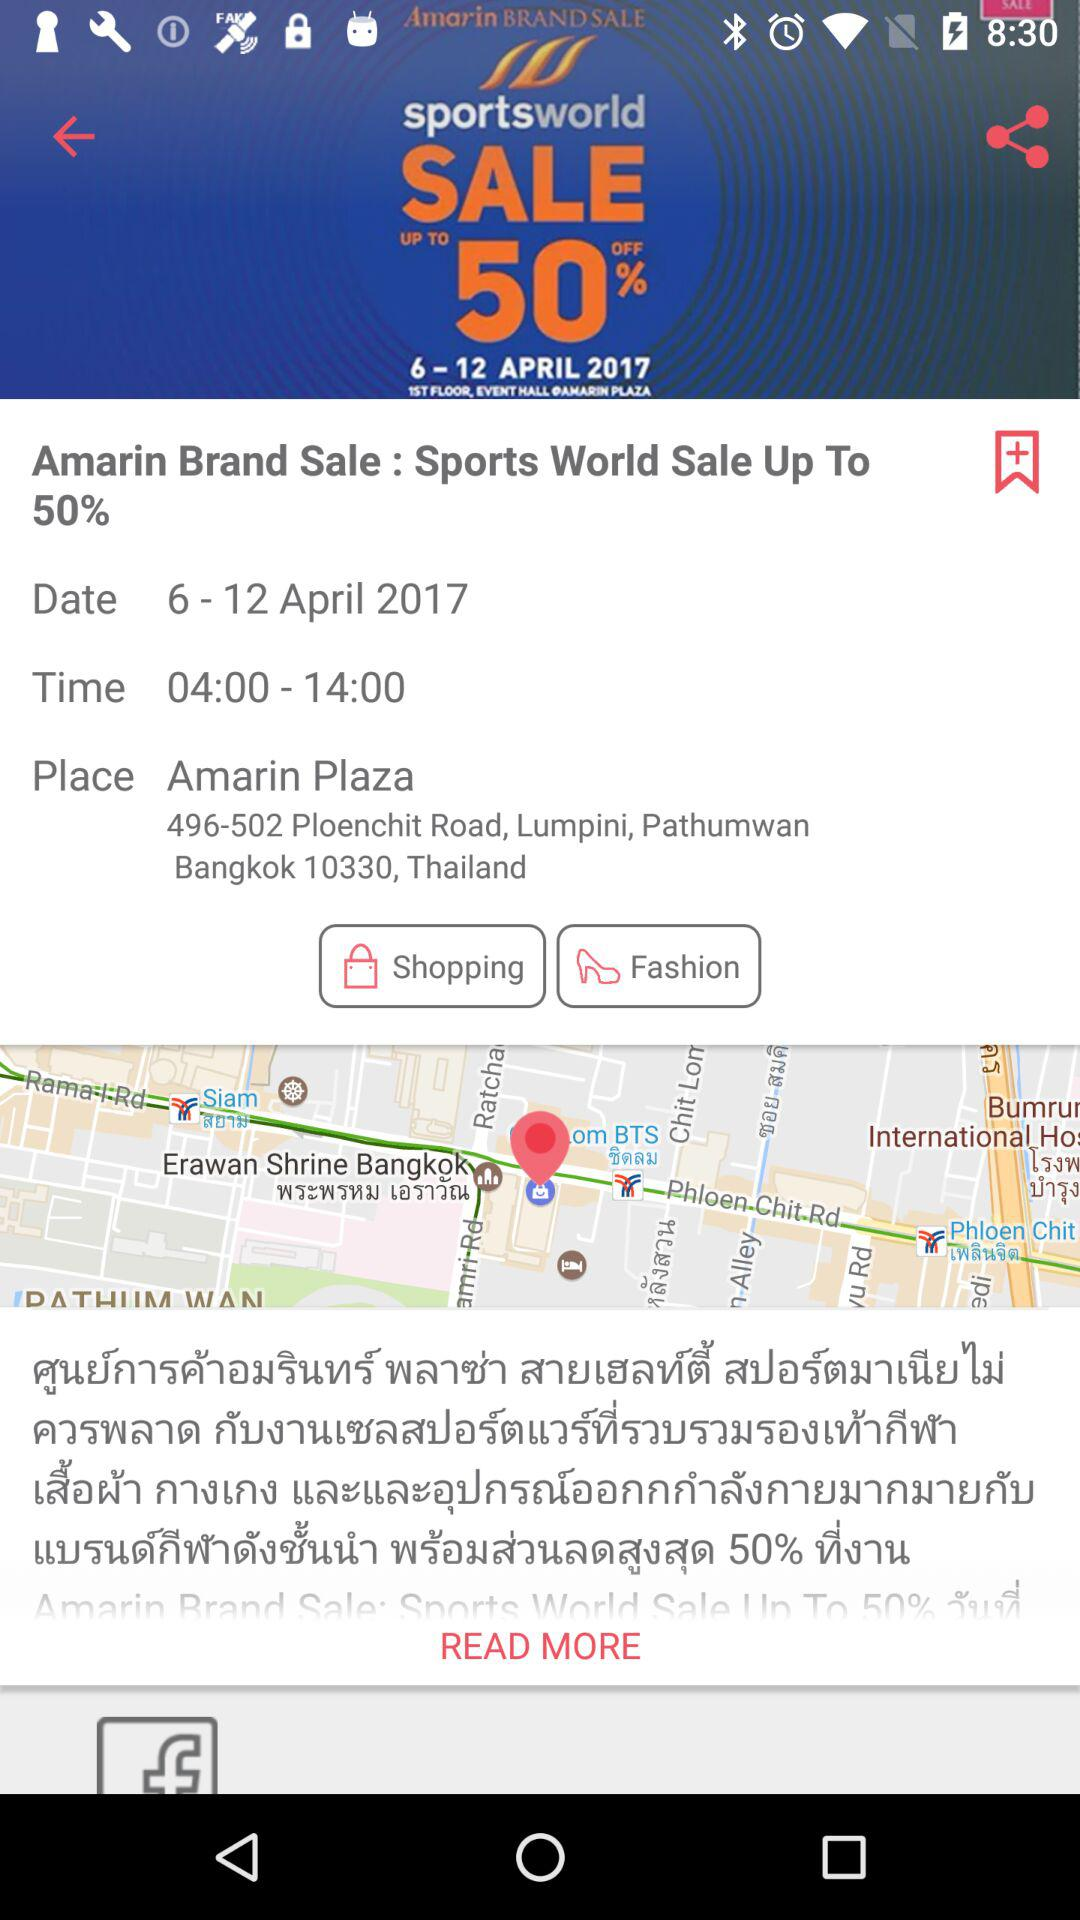What is the address of the event?
Answer the question using a single word or phrase. 496-502 Ploenchit Road, Lumpini, Pathumwan Bangkok 10330, Thailand 